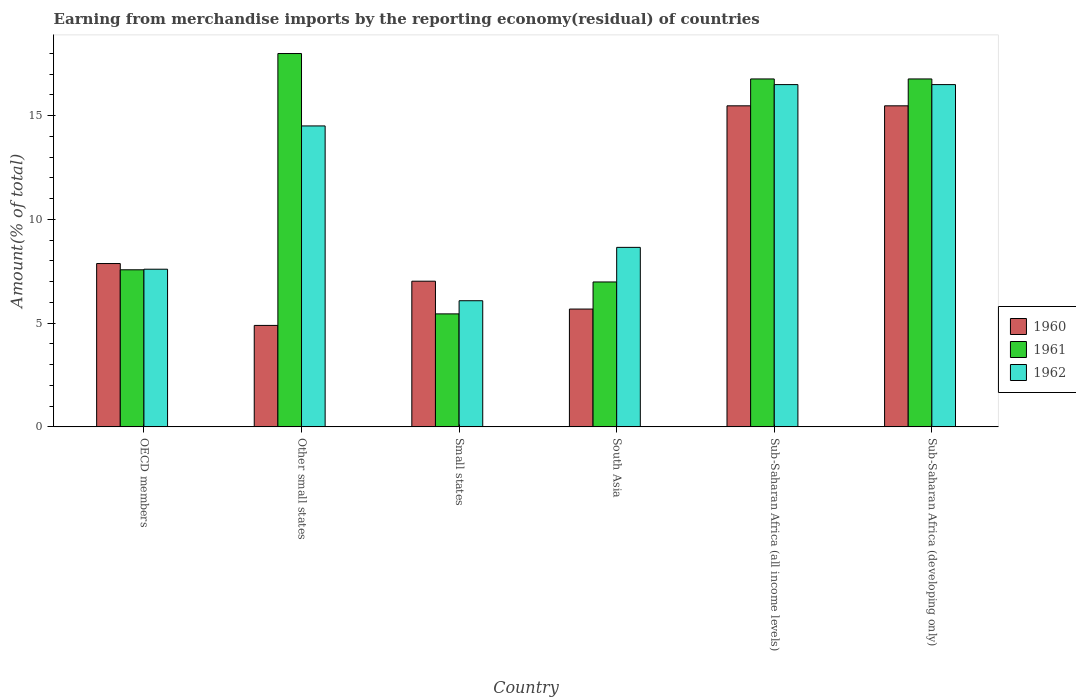How many different coloured bars are there?
Give a very brief answer. 3. How many groups of bars are there?
Offer a very short reply. 6. How many bars are there on the 3rd tick from the left?
Provide a succinct answer. 3. What is the label of the 6th group of bars from the left?
Your response must be concise. Sub-Saharan Africa (developing only). In how many cases, is the number of bars for a given country not equal to the number of legend labels?
Offer a terse response. 0. What is the percentage of amount earned from merchandise imports in 1962 in Other small states?
Provide a short and direct response. 14.51. Across all countries, what is the maximum percentage of amount earned from merchandise imports in 1961?
Provide a succinct answer. 17.99. Across all countries, what is the minimum percentage of amount earned from merchandise imports in 1962?
Provide a succinct answer. 6.08. In which country was the percentage of amount earned from merchandise imports in 1962 maximum?
Keep it short and to the point. Sub-Saharan Africa (all income levels). In which country was the percentage of amount earned from merchandise imports in 1961 minimum?
Give a very brief answer. Small states. What is the total percentage of amount earned from merchandise imports in 1960 in the graph?
Your response must be concise. 56.41. What is the difference between the percentage of amount earned from merchandise imports in 1961 in OECD members and that in Other small states?
Offer a very short reply. -10.42. What is the difference between the percentage of amount earned from merchandise imports in 1962 in OECD members and the percentage of amount earned from merchandise imports in 1961 in Small states?
Offer a very short reply. 2.15. What is the average percentage of amount earned from merchandise imports in 1960 per country?
Make the answer very short. 9.4. What is the difference between the percentage of amount earned from merchandise imports of/in 1962 and percentage of amount earned from merchandise imports of/in 1960 in OECD members?
Your answer should be very brief. -0.27. What is the ratio of the percentage of amount earned from merchandise imports in 1962 in OECD members to that in Sub-Saharan Africa (developing only)?
Keep it short and to the point. 0.46. What is the difference between the highest and the second highest percentage of amount earned from merchandise imports in 1960?
Provide a short and direct response. -7.6. What is the difference between the highest and the lowest percentage of amount earned from merchandise imports in 1962?
Ensure brevity in your answer.  10.42. In how many countries, is the percentage of amount earned from merchandise imports in 1961 greater than the average percentage of amount earned from merchandise imports in 1961 taken over all countries?
Give a very brief answer. 3. What does the 2nd bar from the left in Small states represents?
Ensure brevity in your answer.  1961. What does the 3rd bar from the right in Other small states represents?
Provide a succinct answer. 1960. Are all the bars in the graph horizontal?
Keep it short and to the point. No. How many countries are there in the graph?
Offer a very short reply. 6. Are the values on the major ticks of Y-axis written in scientific E-notation?
Offer a very short reply. No. Does the graph contain grids?
Keep it short and to the point. No. Where does the legend appear in the graph?
Offer a very short reply. Center right. How many legend labels are there?
Make the answer very short. 3. What is the title of the graph?
Offer a very short reply. Earning from merchandise imports by the reporting economy(residual) of countries. What is the label or title of the Y-axis?
Give a very brief answer. Amount(% of total). What is the Amount(% of total) in 1960 in OECD members?
Provide a succinct answer. 7.87. What is the Amount(% of total) in 1961 in OECD members?
Give a very brief answer. 7.57. What is the Amount(% of total) in 1962 in OECD members?
Give a very brief answer. 7.6. What is the Amount(% of total) of 1960 in Other small states?
Your response must be concise. 4.89. What is the Amount(% of total) in 1961 in Other small states?
Offer a terse response. 17.99. What is the Amount(% of total) of 1962 in Other small states?
Keep it short and to the point. 14.51. What is the Amount(% of total) in 1960 in Small states?
Your response must be concise. 7.02. What is the Amount(% of total) of 1961 in Small states?
Your answer should be very brief. 5.45. What is the Amount(% of total) of 1962 in Small states?
Provide a succinct answer. 6.08. What is the Amount(% of total) of 1960 in South Asia?
Give a very brief answer. 5.68. What is the Amount(% of total) of 1961 in South Asia?
Offer a terse response. 6.98. What is the Amount(% of total) in 1962 in South Asia?
Give a very brief answer. 8.65. What is the Amount(% of total) in 1960 in Sub-Saharan Africa (all income levels)?
Provide a succinct answer. 15.47. What is the Amount(% of total) in 1961 in Sub-Saharan Africa (all income levels)?
Provide a short and direct response. 16.77. What is the Amount(% of total) of 1962 in Sub-Saharan Africa (all income levels)?
Ensure brevity in your answer.  16.5. What is the Amount(% of total) in 1960 in Sub-Saharan Africa (developing only)?
Your answer should be very brief. 15.47. What is the Amount(% of total) of 1961 in Sub-Saharan Africa (developing only)?
Offer a terse response. 16.77. What is the Amount(% of total) in 1962 in Sub-Saharan Africa (developing only)?
Your answer should be compact. 16.5. Across all countries, what is the maximum Amount(% of total) in 1960?
Give a very brief answer. 15.47. Across all countries, what is the maximum Amount(% of total) of 1961?
Give a very brief answer. 17.99. Across all countries, what is the maximum Amount(% of total) in 1962?
Offer a terse response. 16.5. Across all countries, what is the minimum Amount(% of total) of 1960?
Offer a very short reply. 4.89. Across all countries, what is the minimum Amount(% of total) in 1961?
Your answer should be compact. 5.45. Across all countries, what is the minimum Amount(% of total) of 1962?
Your response must be concise. 6.08. What is the total Amount(% of total) in 1960 in the graph?
Your response must be concise. 56.41. What is the total Amount(% of total) of 1961 in the graph?
Provide a succinct answer. 71.54. What is the total Amount(% of total) of 1962 in the graph?
Give a very brief answer. 69.83. What is the difference between the Amount(% of total) in 1960 in OECD members and that in Other small states?
Ensure brevity in your answer.  2.98. What is the difference between the Amount(% of total) in 1961 in OECD members and that in Other small states?
Ensure brevity in your answer.  -10.42. What is the difference between the Amount(% of total) in 1962 in OECD members and that in Other small states?
Your answer should be very brief. -6.91. What is the difference between the Amount(% of total) of 1960 in OECD members and that in Small states?
Your answer should be compact. 0.85. What is the difference between the Amount(% of total) in 1961 in OECD members and that in Small states?
Provide a short and direct response. 2.13. What is the difference between the Amount(% of total) in 1962 in OECD members and that in Small states?
Provide a short and direct response. 1.52. What is the difference between the Amount(% of total) of 1960 in OECD members and that in South Asia?
Your answer should be very brief. 2.19. What is the difference between the Amount(% of total) of 1961 in OECD members and that in South Asia?
Keep it short and to the point. 0.59. What is the difference between the Amount(% of total) in 1962 in OECD members and that in South Asia?
Your response must be concise. -1.05. What is the difference between the Amount(% of total) in 1960 in OECD members and that in Sub-Saharan Africa (all income levels)?
Ensure brevity in your answer.  -7.6. What is the difference between the Amount(% of total) of 1961 in OECD members and that in Sub-Saharan Africa (all income levels)?
Provide a short and direct response. -9.2. What is the difference between the Amount(% of total) of 1962 in OECD members and that in Sub-Saharan Africa (all income levels)?
Keep it short and to the point. -8.9. What is the difference between the Amount(% of total) in 1960 in OECD members and that in Sub-Saharan Africa (developing only)?
Make the answer very short. -7.6. What is the difference between the Amount(% of total) in 1961 in OECD members and that in Sub-Saharan Africa (developing only)?
Make the answer very short. -9.2. What is the difference between the Amount(% of total) of 1962 in OECD members and that in Sub-Saharan Africa (developing only)?
Offer a terse response. -8.9. What is the difference between the Amount(% of total) in 1960 in Other small states and that in Small states?
Make the answer very short. -2.13. What is the difference between the Amount(% of total) of 1961 in Other small states and that in Small states?
Provide a short and direct response. 12.55. What is the difference between the Amount(% of total) in 1962 in Other small states and that in Small states?
Give a very brief answer. 8.42. What is the difference between the Amount(% of total) in 1960 in Other small states and that in South Asia?
Your answer should be compact. -0.79. What is the difference between the Amount(% of total) of 1961 in Other small states and that in South Asia?
Ensure brevity in your answer.  11.01. What is the difference between the Amount(% of total) of 1962 in Other small states and that in South Asia?
Provide a succinct answer. 5.85. What is the difference between the Amount(% of total) of 1960 in Other small states and that in Sub-Saharan Africa (all income levels)?
Keep it short and to the point. -10.58. What is the difference between the Amount(% of total) in 1961 in Other small states and that in Sub-Saharan Africa (all income levels)?
Ensure brevity in your answer.  1.22. What is the difference between the Amount(% of total) of 1962 in Other small states and that in Sub-Saharan Africa (all income levels)?
Your response must be concise. -1.99. What is the difference between the Amount(% of total) of 1960 in Other small states and that in Sub-Saharan Africa (developing only)?
Provide a short and direct response. -10.58. What is the difference between the Amount(% of total) of 1961 in Other small states and that in Sub-Saharan Africa (developing only)?
Provide a succinct answer. 1.22. What is the difference between the Amount(% of total) in 1962 in Other small states and that in Sub-Saharan Africa (developing only)?
Ensure brevity in your answer.  -1.99. What is the difference between the Amount(% of total) in 1960 in Small states and that in South Asia?
Ensure brevity in your answer.  1.34. What is the difference between the Amount(% of total) in 1961 in Small states and that in South Asia?
Your answer should be very brief. -1.54. What is the difference between the Amount(% of total) of 1962 in Small states and that in South Asia?
Offer a very short reply. -2.57. What is the difference between the Amount(% of total) of 1960 in Small states and that in Sub-Saharan Africa (all income levels)?
Your answer should be very brief. -8.45. What is the difference between the Amount(% of total) in 1961 in Small states and that in Sub-Saharan Africa (all income levels)?
Give a very brief answer. -11.32. What is the difference between the Amount(% of total) of 1962 in Small states and that in Sub-Saharan Africa (all income levels)?
Your answer should be very brief. -10.42. What is the difference between the Amount(% of total) of 1960 in Small states and that in Sub-Saharan Africa (developing only)?
Offer a terse response. -8.45. What is the difference between the Amount(% of total) in 1961 in Small states and that in Sub-Saharan Africa (developing only)?
Make the answer very short. -11.32. What is the difference between the Amount(% of total) in 1962 in Small states and that in Sub-Saharan Africa (developing only)?
Offer a very short reply. -10.42. What is the difference between the Amount(% of total) in 1960 in South Asia and that in Sub-Saharan Africa (all income levels)?
Your answer should be very brief. -9.8. What is the difference between the Amount(% of total) of 1961 in South Asia and that in Sub-Saharan Africa (all income levels)?
Offer a very short reply. -9.79. What is the difference between the Amount(% of total) of 1962 in South Asia and that in Sub-Saharan Africa (all income levels)?
Give a very brief answer. -7.84. What is the difference between the Amount(% of total) of 1960 in South Asia and that in Sub-Saharan Africa (developing only)?
Ensure brevity in your answer.  -9.8. What is the difference between the Amount(% of total) in 1961 in South Asia and that in Sub-Saharan Africa (developing only)?
Your answer should be compact. -9.79. What is the difference between the Amount(% of total) in 1962 in South Asia and that in Sub-Saharan Africa (developing only)?
Your answer should be compact. -7.84. What is the difference between the Amount(% of total) of 1960 in OECD members and the Amount(% of total) of 1961 in Other small states?
Offer a very short reply. -10.12. What is the difference between the Amount(% of total) in 1960 in OECD members and the Amount(% of total) in 1962 in Other small states?
Ensure brevity in your answer.  -6.63. What is the difference between the Amount(% of total) in 1961 in OECD members and the Amount(% of total) in 1962 in Other small states?
Ensure brevity in your answer.  -6.93. What is the difference between the Amount(% of total) in 1960 in OECD members and the Amount(% of total) in 1961 in Small states?
Your answer should be compact. 2.43. What is the difference between the Amount(% of total) of 1960 in OECD members and the Amount(% of total) of 1962 in Small states?
Give a very brief answer. 1.79. What is the difference between the Amount(% of total) of 1961 in OECD members and the Amount(% of total) of 1962 in Small states?
Offer a terse response. 1.49. What is the difference between the Amount(% of total) in 1960 in OECD members and the Amount(% of total) in 1961 in South Asia?
Your answer should be compact. 0.89. What is the difference between the Amount(% of total) in 1960 in OECD members and the Amount(% of total) in 1962 in South Asia?
Provide a short and direct response. -0.78. What is the difference between the Amount(% of total) of 1961 in OECD members and the Amount(% of total) of 1962 in South Asia?
Provide a short and direct response. -1.08. What is the difference between the Amount(% of total) of 1960 in OECD members and the Amount(% of total) of 1961 in Sub-Saharan Africa (all income levels)?
Your answer should be compact. -8.9. What is the difference between the Amount(% of total) in 1960 in OECD members and the Amount(% of total) in 1962 in Sub-Saharan Africa (all income levels)?
Offer a very short reply. -8.62. What is the difference between the Amount(% of total) of 1961 in OECD members and the Amount(% of total) of 1962 in Sub-Saharan Africa (all income levels)?
Keep it short and to the point. -8.93. What is the difference between the Amount(% of total) of 1960 in OECD members and the Amount(% of total) of 1961 in Sub-Saharan Africa (developing only)?
Give a very brief answer. -8.9. What is the difference between the Amount(% of total) of 1960 in OECD members and the Amount(% of total) of 1962 in Sub-Saharan Africa (developing only)?
Offer a very short reply. -8.62. What is the difference between the Amount(% of total) in 1961 in OECD members and the Amount(% of total) in 1962 in Sub-Saharan Africa (developing only)?
Your answer should be very brief. -8.93. What is the difference between the Amount(% of total) in 1960 in Other small states and the Amount(% of total) in 1961 in Small states?
Provide a succinct answer. -0.56. What is the difference between the Amount(% of total) of 1960 in Other small states and the Amount(% of total) of 1962 in Small states?
Give a very brief answer. -1.19. What is the difference between the Amount(% of total) of 1961 in Other small states and the Amount(% of total) of 1962 in Small states?
Your response must be concise. 11.91. What is the difference between the Amount(% of total) in 1960 in Other small states and the Amount(% of total) in 1961 in South Asia?
Offer a very short reply. -2.09. What is the difference between the Amount(% of total) in 1960 in Other small states and the Amount(% of total) in 1962 in South Asia?
Provide a short and direct response. -3.76. What is the difference between the Amount(% of total) of 1961 in Other small states and the Amount(% of total) of 1962 in South Asia?
Keep it short and to the point. 9.34. What is the difference between the Amount(% of total) in 1960 in Other small states and the Amount(% of total) in 1961 in Sub-Saharan Africa (all income levels)?
Provide a short and direct response. -11.88. What is the difference between the Amount(% of total) of 1960 in Other small states and the Amount(% of total) of 1962 in Sub-Saharan Africa (all income levels)?
Offer a very short reply. -11.61. What is the difference between the Amount(% of total) of 1961 in Other small states and the Amount(% of total) of 1962 in Sub-Saharan Africa (all income levels)?
Keep it short and to the point. 1.5. What is the difference between the Amount(% of total) of 1960 in Other small states and the Amount(% of total) of 1961 in Sub-Saharan Africa (developing only)?
Provide a short and direct response. -11.88. What is the difference between the Amount(% of total) in 1960 in Other small states and the Amount(% of total) in 1962 in Sub-Saharan Africa (developing only)?
Give a very brief answer. -11.61. What is the difference between the Amount(% of total) of 1961 in Other small states and the Amount(% of total) of 1962 in Sub-Saharan Africa (developing only)?
Your response must be concise. 1.5. What is the difference between the Amount(% of total) in 1960 in Small states and the Amount(% of total) in 1961 in South Asia?
Your answer should be compact. 0.04. What is the difference between the Amount(% of total) of 1960 in Small states and the Amount(% of total) of 1962 in South Asia?
Offer a very short reply. -1.63. What is the difference between the Amount(% of total) of 1961 in Small states and the Amount(% of total) of 1962 in South Asia?
Keep it short and to the point. -3.21. What is the difference between the Amount(% of total) in 1960 in Small states and the Amount(% of total) in 1961 in Sub-Saharan Africa (all income levels)?
Give a very brief answer. -9.75. What is the difference between the Amount(% of total) in 1960 in Small states and the Amount(% of total) in 1962 in Sub-Saharan Africa (all income levels)?
Provide a succinct answer. -9.48. What is the difference between the Amount(% of total) of 1961 in Small states and the Amount(% of total) of 1962 in Sub-Saharan Africa (all income levels)?
Provide a short and direct response. -11.05. What is the difference between the Amount(% of total) of 1960 in Small states and the Amount(% of total) of 1961 in Sub-Saharan Africa (developing only)?
Your response must be concise. -9.75. What is the difference between the Amount(% of total) of 1960 in Small states and the Amount(% of total) of 1962 in Sub-Saharan Africa (developing only)?
Give a very brief answer. -9.48. What is the difference between the Amount(% of total) of 1961 in Small states and the Amount(% of total) of 1962 in Sub-Saharan Africa (developing only)?
Keep it short and to the point. -11.05. What is the difference between the Amount(% of total) of 1960 in South Asia and the Amount(% of total) of 1961 in Sub-Saharan Africa (all income levels)?
Offer a terse response. -11.09. What is the difference between the Amount(% of total) of 1960 in South Asia and the Amount(% of total) of 1962 in Sub-Saharan Africa (all income levels)?
Provide a succinct answer. -10.82. What is the difference between the Amount(% of total) in 1961 in South Asia and the Amount(% of total) in 1962 in Sub-Saharan Africa (all income levels)?
Ensure brevity in your answer.  -9.51. What is the difference between the Amount(% of total) in 1960 in South Asia and the Amount(% of total) in 1961 in Sub-Saharan Africa (developing only)?
Your answer should be very brief. -11.09. What is the difference between the Amount(% of total) of 1960 in South Asia and the Amount(% of total) of 1962 in Sub-Saharan Africa (developing only)?
Provide a short and direct response. -10.82. What is the difference between the Amount(% of total) of 1961 in South Asia and the Amount(% of total) of 1962 in Sub-Saharan Africa (developing only)?
Ensure brevity in your answer.  -9.51. What is the difference between the Amount(% of total) of 1960 in Sub-Saharan Africa (all income levels) and the Amount(% of total) of 1961 in Sub-Saharan Africa (developing only)?
Provide a short and direct response. -1.3. What is the difference between the Amount(% of total) in 1960 in Sub-Saharan Africa (all income levels) and the Amount(% of total) in 1962 in Sub-Saharan Africa (developing only)?
Your answer should be very brief. -1.02. What is the difference between the Amount(% of total) of 1961 in Sub-Saharan Africa (all income levels) and the Amount(% of total) of 1962 in Sub-Saharan Africa (developing only)?
Ensure brevity in your answer.  0.27. What is the average Amount(% of total) in 1960 per country?
Provide a short and direct response. 9.4. What is the average Amount(% of total) in 1961 per country?
Make the answer very short. 11.92. What is the average Amount(% of total) in 1962 per country?
Your response must be concise. 11.64. What is the difference between the Amount(% of total) of 1960 and Amount(% of total) of 1961 in OECD members?
Provide a succinct answer. 0.3. What is the difference between the Amount(% of total) in 1960 and Amount(% of total) in 1962 in OECD members?
Keep it short and to the point. 0.27. What is the difference between the Amount(% of total) in 1961 and Amount(% of total) in 1962 in OECD members?
Keep it short and to the point. -0.03. What is the difference between the Amount(% of total) in 1960 and Amount(% of total) in 1961 in Other small states?
Your response must be concise. -13.1. What is the difference between the Amount(% of total) of 1960 and Amount(% of total) of 1962 in Other small states?
Ensure brevity in your answer.  -9.62. What is the difference between the Amount(% of total) in 1961 and Amount(% of total) in 1962 in Other small states?
Offer a terse response. 3.49. What is the difference between the Amount(% of total) of 1960 and Amount(% of total) of 1961 in Small states?
Provide a short and direct response. 1.58. What is the difference between the Amount(% of total) of 1960 and Amount(% of total) of 1962 in Small states?
Provide a succinct answer. 0.94. What is the difference between the Amount(% of total) in 1961 and Amount(% of total) in 1962 in Small states?
Make the answer very short. -0.63. What is the difference between the Amount(% of total) in 1960 and Amount(% of total) in 1961 in South Asia?
Give a very brief answer. -1.31. What is the difference between the Amount(% of total) of 1960 and Amount(% of total) of 1962 in South Asia?
Offer a terse response. -2.97. What is the difference between the Amount(% of total) in 1961 and Amount(% of total) in 1962 in South Asia?
Offer a very short reply. -1.67. What is the difference between the Amount(% of total) of 1960 and Amount(% of total) of 1961 in Sub-Saharan Africa (all income levels)?
Make the answer very short. -1.3. What is the difference between the Amount(% of total) in 1960 and Amount(% of total) in 1962 in Sub-Saharan Africa (all income levels)?
Provide a short and direct response. -1.02. What is the difference between the Amount(% of total) in 1961 and Amount(% of total) in 1962 in Sub-Saharan Africa (all income levels)?
Make the answer very short. 0.27. What is the difference between the Amount(% of total) of 1960 and Amount(% of total) of 1961 in Sub-Saharan Africa (developing only)?
Keep it short and to the point. -1.3. What is the difference between the Amount(% of total) in 1960 and Amount(% of total) in 1962 in Sub-Saharan Africa (developing only)?
Ensure brevity in your answer.  -1.02. What is the difference between the Amount(% of total) of 1961 and Amount(% of total) of 1962 in Sub-Saharan Africa (developing only)?
Your answer should be compact. 0.27. What is the ratio of the Amount(% of total) in 1960 in OECD members to that in Other small states?
Your response must be concise. 1.61. What is the ratio of the Amount(% of total) in 1961 in OECD members to that in Other small states?
Provide a succinct answer. 0.42. What is the ratio of the Amount(% of total) in 1962 in OECD members to that in Other small states?
Provide a short and direct response. 0.52. What is the ratio of the Amount(% of total) of 1960 in OECD members to that in Small states?
Your answer should be very brief. 1.12. What is the ratio of the Amount(% of total) in 1961 in OECD members to that in Small states?
Your response must be concise. 1.39. What is the ratio of the Amount(% of total) of 1962 in OECD members to that in Small states?
Give a very brief answer. 1.25. What is the ratio of the Amount(% of total) in 1960 in OECD members to that in South Asia?
Your answer should be compact. 1.39. What is the ratio of the Amount(% of total) of 1961 in OECD members to that in South Asia?
Your response must be concise. 1.08. What is the ratio of the Amount(% of total) of 1962 in OECD members to that in South Asia?
Give a very brief answer. 0.88. What is the ratio of the Amount(% of total) in 1960 in OECD members to that in Sub-Saharan Africa (all income levels)?
Keep it short and to the point. 0.51. What is the ratio of the Amount(% of total) in 1961 in OECD members to that in Sub-Saharan Africa (all income levels)?
Keep it short and to the point. 0.45. What is the ratio of the Amount(% of total) of 1962 in OECD members to that in Sub-Saharan Africa (all income levels)?
Your answer should be compact. 0.46. What is the ratio of the Amount(% of total) in 1960 in OECD members to that in Sub-Saharan Africa (developing only)?
Your answer should be compact. 0.51. What is the ratio of the Amount(% of total) of 1961 in OECD members to that in Sub-Saharan Africa (developing only)?
Offer a very short reply. 0.45. What is the ratio of the Amount(% of total) in 1962 in OECD members to that in Sub-Saharan Africa (developing only)?
Ensure brevity in your answer.  0.46. What is the ratio of the Amount(% of total) in 1960 in Other small states to that in Small states?
Offer a terse response. 0.7. What is the ratio of the Amount(% of total) in 1961 in Other small states to that in Small states?
Offer a terse response. 3.3. What is the ratio of the Amount(% of total) of 1962 in Other small states to that in Small states?
Your answer should be compact. 2.39. What is the ratio of the Amount(% of total) in 1960 in Other small states to that in South Asia?
Ensure brevity in your answer.  0.86. What is the ratio of the Amount(% of total) in 1961 in Other small states to that in South Asia?
Give a very brief answer. 2.58. What is the ratio of the Amount(% of total) of 1962 in Other small states to that in South Asia?
Offer a very short reply. 1.68. What is the ratio of the Amount(% of total) of 1960 in Other small states to that in Sub-Saharan Africa (all income levels)?
Provide a short and direct response. 0.32. What is the ratio of the Amount(% of total) in 1961 in Other small states to that in Sub-Saharan Africa (all income levels)?
Provide a short and direct response. 1.07. What is the ratio of the Amount(% of total) of 1962 in Other small states to that in Sub-Saharan Africa (all income levels)?
Give a very brief answer. 0.88. What is the ratio of the Amount(% of total) of 1960 in Other small states to that in Sub-Saharan Africa (developing only)?
Your response must be concise. 0.32. What is the ratio of the Amount(% of total) in 1961 in Other small states to that in Sub-Saharan Africa (developing only)?
Offer a very short reply. 1.07. What is the ratio of the Amount(% of total) in 1962 in Other small states to that in Sub-Saharan Africa (developing only)?
Keep it short and to the point. 0.88. What is the ratio of the Amount(% of total) in 1960 in Small states to that in South Asia?
Ensure brevity in your answer.  1.24. What is the ratio of the Amount(% of total) in 1961 in Small states to that in South Asia?
Your answer should be very brief. 0.78. What is the ratio of the Amount(% of total) in 1962 in Small states to that in South Asia?
Give a very brief answer. 0.7. What is the ratio of the Amount(% of total) in 1960 in Small states to that in Sub-Saharan Africa (all income levels)?
Ensure brevity in your answer.  0.45. What is the ratio of the Amount(% of total) of 1961 in Small states to that in Sub-Saharan Africa (all income levels)?
Make the answer very short. 0.32. What is the ratio of the Amount(% of total) in 1962 in Small states to that in Sub-Saharan Africa (all income levels)?
Your answer should be very brief. 0.37. What is the ratio of the Amount(% of total) in 1960 in Small states to that in Sub-Saharan Africa (developing only)?
Ensure brevity in your answer.  0.45. What is the ratio of the Amount(% of total) of 1961 in Small states to that in Sub-Saharan Africa (developing only)?
Your answer should be compact. 0.32. What is the ratio of the Amount(% of total) of 1962 in Small states to that in Sub-Saharan Africa (developing only)?
Ensure brevity in your answer.  0.37. What is the ratio of the Amount(% of total) of 1960 in South Asia to that in Sub-Saharan Africa (all income levels)?
Provide a short and direct response. 0.37. What is the ratio of the Amount(% of total) of 1961 in South Asia to that in Sub-Saharan Africa (all income levels)?
Provide a short and direct response. 0.42. What is the ratio of the Amount(% of total) of 1962 in South Asia to that in Sub-Saharan Africa (all income levels)?
Your answer should be very brief. 0.52. What is the ratio of the Amount(% of total) in 1960 in South Asia to that in Sub-Saharan Africa (developing only)?
Offer a very short reply. 0.37. What is the ratio of the Amount(% of total) in 1961 in South Asia to that in Sub-Saharan Africa (developing only)?
Make the answer very short. 0.42. What is the ratio of the Amount(% of total) in 1962 in South Asia to that in Sub-Saharan Africa (developing only)?
Your response must be concise. 0.52. What is the ratio of the Amount(% of total) in 1960 in Sub-Saharan Africa (all income levels) to that in Sub-Saharan Africa (developing only)?
Keep it short and to the point. 1. What is the ratio of the Amount(% of total) in 1961 in Sub-Saharan Africa (all income levels) to that in Sub-Saharan Africa (developing only)?
Ensure brevity in your answer.  1. What is the difference between the highest and the second highest Amount(% of total) of 1961?
Ensure brevity in your answer.  1.22. What is the difference between the highest and the second highest Amount(% of total) in 1962?
Offer a very short reply. 0. What is the difference between the highest and the lowest Amount(% of total) in 1960?
Provide a succinct answer. 10.58. What is the difference between the highest and the lowest Amount(% of total) in 1961?
Offer a terse response. 12.55. What is the difference between the highest and the lowest Amount(% of total) of 1962?
Your answer should be compact. 10.42. 